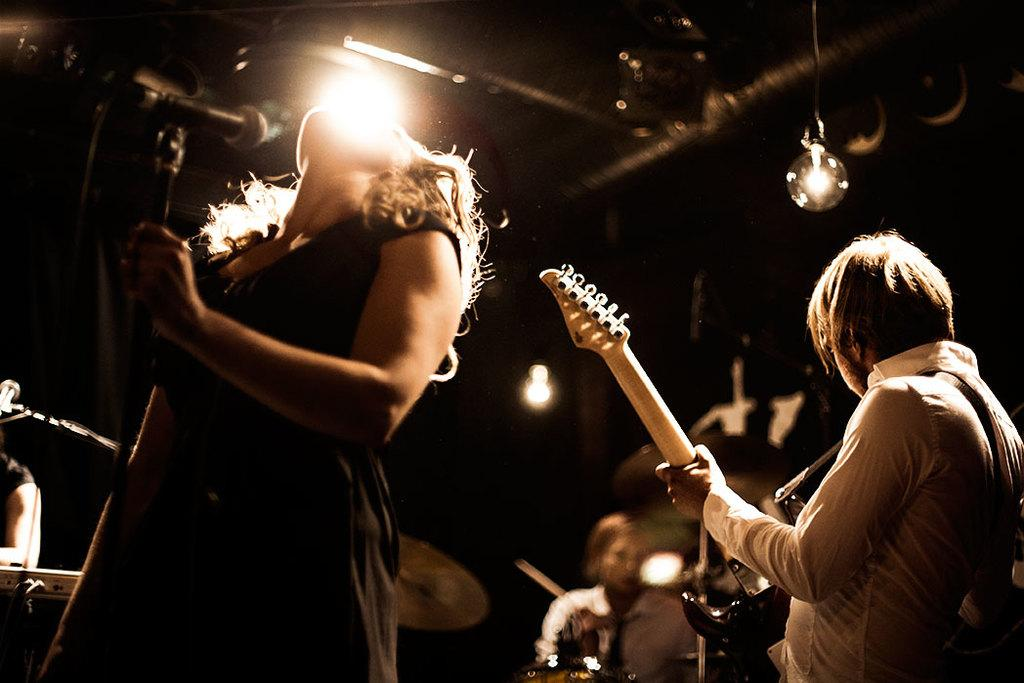What is the main subject of the image? The main subject of the image is a woman. What is the woman doing in the image? The woman is singing on a mic. Are there any other people in the image? Yes, there are other persons in the image. What are the other persons doing? The other persons are playing musical instruments. Can you describe the lighting in the image? There is a light focusing on the performers. Can you see a boat in the image? No, there is no boat present in the image. What type of tail is attached to the woman in the image? There is no tail attached to the woman in the image. 